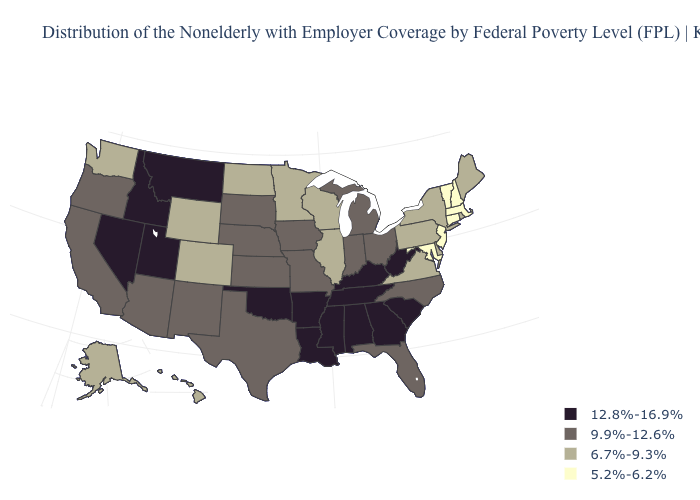Does Illinois have the lowest value in the MidWest?
Be succinct. Yes. Which states have the lowest value in the USA?
Be succinct. Connecticut, Maryland, Massachusetts, New Hampshire, New Jersey, Vermont. What is the highest value in states that border Indiana?
Write a very short answer. 12.8%-16.9%. What is the value of Wisconsin?
Quick response, please. 6.7%-9.3%. Which states have the lowest value in the MidWest?
Keep it brief. Illinois, Minnesota, North Dakota, Wisconsin. What is the value of Kansas?
Answer briefly. 9.9%-12.6%. What is the value of Texas?
Short answer required. 9.9%-12.6%. What is the value of Montana?
Quick response, please. 12.8%-16.9%. Does Delaware have the same value as Virginia?
Keep it brief. Yes. What is the lowest value in the West?
Give a very brief answer. 6.7%-9.3%. Does New Jersey have a lower value than Maine?
Short answer required. Yes. Does Nevada have the lowest value in the USA?
Concise answer only. No. What is the value of Florida?
Keep it brief. 9.9%-12.6%. Which states have the lowest value in the USA?
Answer briefly. Connecticut, Maryland, Massachusetts, New Hampshire, New Jersey, Vermont. 